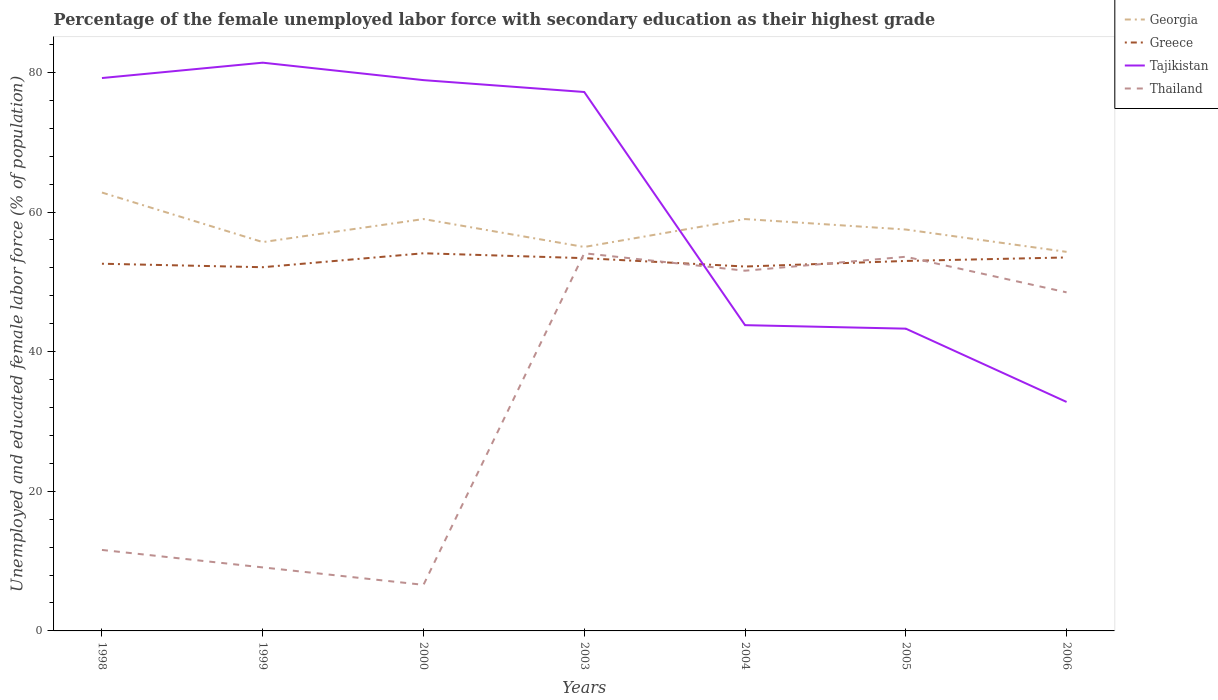Does the line corresponding to Thailand intersect with the line corresponding to Greece?
Offer a terse response. Yes. Is the number of lines equal to the number of legend labels?
Offer a terse response. Yes. Across all years, what is the maximum percentage of the unemployed female labor force with secondary education in Georgia?
Ensure brevity in your answer.  54.3. What is the total percentage of the unemployed female labor force with secondary education in Thailand in the graph?
Offer a terse response. 2.5. What is the difference between the highest and the second highest percentage of the unemployed female labor force with secondary education in Tajikistan?
Make the answer very short. 48.6. Is the percentage of the unemployed female labor force with secondary education in Georgia strictly greater than the percentage of the unemployed female labor force with secondary education in Tajikistan over the years?
Your answer should be compact. No. How many lines are there?
Give a very brief answer. 4. What is the difference between two consecutive major ticks on the Y-axis?
Your answer should be compact. 20. Are the values on the major ticks of Y-axis written in scientific E-notation?
Your response must be concise. No. Does the graph contain any zero values?
Offer a very short reply. No. Where does the legend appear in the graph?
Keep it short and to the point. Top right. How many legend labels are there?
Provide a short and direct response. 4. What is the title of the graph?
Your answer should be compact. Percentage of the female unemployed labor force with secondary education as their highest grade. What is the label or title of the Y-axis?
Keep it short and to the point. Unemployed and educated female labor force (% of population). What is the Unemployed and educated female labor force (% of population) of Georgia in 1998?
Make the answer very short. 62.8. What is the Unemployed and educated female labor force (% of population) in Greece in 1998?
Keep it short and to the point. 52.6. What is the Unemployed and educated female labor force (% of population) in Tajikistan in 1998?
Your answer should be very brief. 79.2. What is the Unemployed and educated female labor force (% of population) in Thailand in 1998?
Your answer should be compact. 11.6. What is the Unemployed and educated female labor force (% of population) in Georgia in 1999?
Keep it short and to the point. 55.7. What is the Unemployed and educated female labor force (% of population) in Greece in 1999?
Offer a terse response. 52.1. What is the Unemployed and educated female labor force (% of population) of Tajikistan in 1999?
Your answer should be very brief. 81.4. What is the Unemployed and educated female labor force (% of population) of Thailand in 1999?
Provide a succinct answer. 9.1. What is the Unemployed and educated female labor force (% of population) of Greece in 2000?
Provide a short and direct response. 54.1. What is the Unemployed and educated female labor force (% of population) of Tajikistan in 2000?
Give a very brief answer. 78.9. What is the Unemployed and educated female labor force (% of population) of Thailand in 2000?
Your response must be concise. 6.6. What is the Unemployed and educated female labor force (% of population) of Greece in 2003?
Offer a terse response. 53.4. What is the Unemployed and educated female labor force (% of population) in Tajikistan in 2003?
Offer a terse response. 77.2. What is the Unemployed and educated female labor force (% of population) of Thailand in 2003?
Your answer should be very brief. 54.1. What is the Unemployed and educated female labor force (% of population) of Greece in 2004?
Your response must be concise. 52.2. What is the Unemployed and educated female labor force (% of population) of Tajikistan in 2004?
Your answer should be very brief. 43.8. What is the Unemployed and educated female labor force (% of population) in Thailand in 2004?
Ensure brevity in your answer.  51.6. What is the Unemployed and educated female labor force (% of population) of Georgia in 2005?
Your response must be concise. 57.5. What is the Unemployed and educated female labor force (% of population) of Tajikistan in 2005?
Offer a very short reply. 43.3. What is the Unemployed and educated female labor force (% of population) in Thailand in 2005?
Keep it short and to the point. 53.6. What is the Unemployed and educated female labor force (% of population) of Georgia in 2006?
Offer a terse response. 54.3. What is the Unemployed and educated female labor force (% of population) of Greece in 2006?
Provide a short and direct response. 53.5. What is the Unemployed and educated female labor force (% of population) in Tajikistan in 2006?
Your answer should be very brief. 32.8. What is the Unemployed and educated female labor force (% of population) of Thailand in 2006?
Provide a succinct answer. 48.5. Across all years, what is the maximum Unemployed and educated female labor force (% of population) in Georgia?
Your response must be concise. 62.8. Across all years, what is the maximum Unemployed and educated female labor force (% of population) of Greece?
Offer a very short reply. 54.1. Across all years, what is the maximum Unemployed and educated female labor force (% of population) in Tajikistan?
Your answer should be very brief. 81.4. Across all years, what is the maximum Unemployed and educated female labor force (% of population) in Thailand?
Your response must be concise. 54.1. Across all years, what is the minimum Unemployed and educated female labor force (% of population) of Georgia?
Your answer should be compact. 54.3. Across all years, what is the minimum Unemployed and educated female labor force (% of population) of Greece?
Give a very brief answer. 52.1. Across all years, what is the minimum Unemployed and educated female labor force (% of population) in Tajikistan?
Your answer should be compact. 32.8. Across all years, what is the minimum Unemployed and educated female labor force (% of population) of Thailand?
Ensure brevity in your answer.  6.6. What is the total Unemployed and educated female labor force (% of population) of Georgia in the graph?
Your answer should be compact. 403.3. What is the total Unemployed and educated female labor force (% of population) of Greece in the graph?
Provide a succinct answer. 370.9. What is the total Unemployed and educated female labor force (% of population) in Tajikistan in the graph?
Offer a very short reply. 436.6. What is the total Unemployed and educated female labor force (% of population) of Thailand in the graph?
Give a very brief answer. 235.1. What is the difference between the Unemployed and educated female labor force (% of population) of Tajikistan in 1998 and that in 1999?
Give a very brief answer. -2.2. What is the difference between the Unemployed and educated female labor force (% of population) of Thailand in 1998 and that in 1999?
Ensure brevity in your answer.  2.5. What is the difference between the Unemployed and educated female labor force (% of population) of Georgia in 1998 and that in 2000?
Your response must be concise. 3.8. What is the difference between the Unemployed and educated female labor force (% of population) in Greece in 1998 and that in 2000?
Your response must be concise. -1.5. What is the difference between the Unemployed and educated female labor force (% of population) of Tajikistan in 1998 and that in 2000?
Your answer should be very brief. 0.3. What is the difference between the Unemployed and educated female labor force (% of population) in Thailand in 1998 and that in 2000?
Offer a very short reply. 5. What is the difference between the Unemployed and educated female labor force (% of population) in Greece in 1998 and that in 2003?
Your response must be concise. -0.8. What is the difference between the Unemployed and educated female labor force (% of population) of Thailand in 1998 and that in 2003?
Your answer should be compact. -42.5. What is the difference between the Unemployed and educated female labor force (% of population) of Tajikistan in 1998 and that in 2004?
Provide a short and direct response. 35.4. What is the difference between the Unemployed and educated female labor force (% of population) of Thailand in 1998 and that in 2004?
Provide a succinct answer. -40. What is the difference between the Unemployed and educated female labor force (% of population) of Georgia in 1998 and that in 2005?
Make the answer very short. 5.3. What is the difference between the Unemployed and educated female labor force (% of population) of Greece in 1998 and that in 2005?
Your answer should be very brief. -0.4. What is the difference between the Unemployed and educated female labor force (% of population) in Tajikistan in 1998 and that in 2005?
Provide a succinct answer. 35.9. What is the difference between the Unemployed and educated female labor force (% of population) in Thailand in 1998 and that in 2005?
Offer a terse response. -42. What is the difference between the Unemployed and educated female labor force (% of population) of Tajikistan in 1998 and that in 2006?
Make the answer very short. 46.4. What is the difference between the Unemployed and educated female labor force (% of population) of Thailand in 1998 and that in 2006?
Make the answer very short. -36.9. What is the difference between the Unemployed and educated female labor force (% of population) of Tajikistan in 1999 and that in 2000?
Ensure brevity in your answer.  2.5. What is the difference between the Unemployed and educated female labor force (% of population) of Thailand in 1999 and that in 2000?
Your answer should be very brief. 2.5. What is the difference between the Unemployed and educated female labor force (% of population) in Greece in 1999 and that in 2003?
Keep it short and to the point. -1.3. What is the difference between the Unemployed and educated female labor force (% of population) of Tajikistan in 1999 and that in 2003?
Your response must be concise. 4.2. What is the difference between the Unemployed and educated female labor force (% of population) in Thailand in 1999 and that in 2003?
Provide a succinct answer. -45. What is the difference between the Unemployed and educated female labor force (% of population) in Georgia in 1999 and that in 2004?
Your answer should be very brief. -3.3. What is the difference between the Unemployed and educated female labor force (% of population) in Tajikistan in 1999 and that in 2004?
Your answer should be compact. 37.6. What is the difference between the Unemployed and educated female labor force (% of population) in Thailand in 1999 and that in 2004?
Offer a very short reply. -42.5. What is the difference between the Unemployed and educated female labor force (% of population) in Georgia in 1999 and that in 2005?
Provide a succinct answer. -1.8. What is the difference between the Unemployed and educated female labor force (% of population) of Greece in 1999 and that in 2005?
Keep it short and to the point. -0.9. What is the difference between the Unemployed and educated female labor force (% of population) of Tajikistan in 1999 and that in 2005?
Offer a terse response. 38.1. What is the difference between the Unemployed and educated female labor force (% of population) of Thailand in 1999 and that in 2005?
Ensure brevity in your answer.  -44.5. What is the difference between the Unemployed and educated female labor force (% of population) in Tajikistan in 1999 and that in 2006?
Provide a succinct answer. 48.6. What is the difference between the Unemployed and educated female labor force (% of population) in Thailand in 1999 and that in 2006?
Keep it short and to the point. -39.4. What is the difference between the Unemployed and educated female labor force (% of population) in Greece in 2000 and that in 2003?
Your answer should be compact. 0.7. What is the difference between the Unemployed and educated female labor force (% of population) of Tajikistan in 2000 and that in 2003?
Ensure brevity in your answer.  1.7. What is the difference between the Unemployed and educated female labor force (% of population) in Thailand in 2000 and that in 2003?
Provide a succinct answer. -47.5. What is the difference between the Unemployed and educated female labor force (% of population) of Georgia in 2000 and that in 2004?
Provide a succinct answer. 0. What is the difference between the Unemployed and educated female labor force (% of population) in Tajikistan in 2000 and that in 2004?
Offer a terse response. 35.1. What is the difference between the Unemployed and educated female labor force (% of population) in Thailand in 2000 and that in 2004?
Keep it short and to the point. -45. What is the difference between the Unemployed and educated female labor force (% of population) in Georgia in 2000 and that in 2005?
Your answer should be compact. 1.5. What is the difference between the Unemployed and educated female labor force (% of population) in Tajikistan in 2000 and that in 2005?
Offer a very short reply. 35.6. What is the difference between the Unemployed and educated female labor force (% of population) of Thailand in 2000 and that in 2005?
Give a very brief answer. -47. What is the difference between the Unemployed and educated female labor force (% of population) of Tajikistan in 2000 and that in 2006?
Provide a succinct answer. 46.1. What is the difference between the Unemployed and educated female labor force (% of population) in Thailand in 2000 and that in 2006?
Give a very brief answer. -41.9. What is the difference between the Unemployed and educated female labor force (% of population) of Tajikistan in 2003 and that in 2004?
Ensure brevity in your answer.  33.4. What is the difference between the Unemployed and educated female labor force (% of population) in Thailand in 2003 and that in 2004?
Your answer should be compact. 2.5. What is the difference between the Unemployed and educated female labor force (% of population) in Tajikistan in 2003 and that in 2005?
Ensure brevity in your answer.  33.9. What is the difference between the Unemployed and educated female labor force (% of population) of Tajikistan in 2003 and that in 2006?
Ensure brevity in your answer.  44.4. What is the difference between the Unemployed and educated female labor force (% of population) in Greece in 2004 and that in 2005?
Make the answer very short. -0.8. What is the difference between the Unemployed and educated female labor force (% of population) in Tajikistan in 2004 and that in 2005?
Ensure brevity in your answer.  0.5. What is the difference between the Unemployed and educated female labor force (% of population) in Georgia in 2004 and that in 2006?
Give a very brief answer. 4.7. What is the difference between the Unemployed and educated female labor force (% of population) of Greece in 2004 and that in 2006?
Your answer should be compact. -1.3. What is the difference between the Unemployed and educated female labor force (% of population) in Thailand in 2004 and that in 2006?
Offer a terse response. 3.1. What is the difference between the Unemployed and educated female labor force (% of population) of Greece in 2005 and that in 2006?
Offer a terse response. -0.5. What is the difference between the Unemployed and educated female labor force (% of population) in Tajikistan in 2005 and that in 2006?
Keep it short and to the point. 10.5. What is the difference between the Unemployed and educated female labor force (% of population) in Thailand in 2005 and that in 2006?
Make the answer very short. 5.1. What is the difference between the Unemployed and educated female labor force (% of population) in Georgia in 1998 and the Unemployed and educated female labor force (% of population) in Tajikistan in 1999?
Give a very brief answer. -18.6. What is the difference between the Unemployed and educated female labor force (% of population) of Georgia in 1998 and the Unemployed and educated female labor force (% of population) of Thailand in 1999?
Ensure brevity in your answer.  53.7. What is the difference between the Unemployed and educated female labor force (% of population) in Greece in 1998 and the Unemployed and educated female labor force (% of population) in Tajikistan in 1999?
Provide a short and direct response. -28.8. What is the difference between the Unemployed and educated female labor force (% of population) of Greece in 1998 and the Unemployed and educated female labor force (% of population) of Thailand in 1999?
Give a very brief answer. 43.5. What is the difference between the Unemployed and educated female labor force (% of population) in Tajikistan in 1998 and the Unemployed and educated female labor force (% of population) in Thailand in 1999?
Make the answer very short. 70.1. What is the difference between the Unemployed and educated female labor force (% of population) of Georgia in 1998 and the Unemployed and educated female labor force (% of population) of Greece in 2000?
Your response must be concise. 8.7. What is the difference between the Unemployed and educated female labor force (% of population) in Georgia in 1998 and the Unemployed and educated female labor force (% of population) in Tajikistan in 2000?
Your answer should be compact. -16.1. What is the difference between the Unemployed and educated female labor force (% of population) in Georgia in 1998 and the Unemployed and educated female labor force (% of population) in Thailand in 2000?
Your answer should be compact. 56.2. What is the difference between the Unemployed and educated female labor force (% of population) of Greece in 1998 and the Unemployed and educated female labor force (% of population) of Tajikistan in 2000?
Your response must be concise. -26.3. What is the difference between the Unemployed and educated female labor force (% of population) of Greece in 1998 and the Unemployed and educated female labor force (% of population) of Thailand in 2000?
Ensure brevity in your answer.  46. What is the difference between the Unemployed and educated female labor force (% of population) of Tajikistan in 1998 and the Unemployed and educated female labor force (% of population) of Thailand in 2000?
Keep it short and to the point. 72.6. What is the difference between the Unemployed and educated female labor force (% of population) in Georgia in 1998 and the Unemployed and educated female labor force (% of population) in Tajikistan in 2003?
Keep it short and to the point. -14.4. What is the difference between the Unemployed and educated female labor force (% of population) in Georgia in 1998 and the Unemployed and educated female labor force (% of population) in Thailand in 2003?
Offer a terse response. 8.7. What is the difference between the Unemployed and educated female labor force (% of population) of Greece in 1998 and the Unemployed and educated female labor force (% of population) of Tajikistan in 2003?
Your answer should be compact. -24.6. What is the difference between the Unemployed and educated female labor force (% of population) of Greece in 1998 and the Unemployed and educated female labor force (% of population) of Thailand in 2003?
Your answer should be compact. -1.5. What is the difference between the Unemployed and educated female labor force (% of population) in Tajikistan in 1998 and the Unemployed and educated female labor force (% of population) in Thailand in 2003?
Make the answer very short. 25.1. What is the difference between the Unemployed and educated female labor force (% of population) in Georgia in 1998 and the Unemployed and educated female labor force (% of population) in Greece in 2004?
Give a very brief answer. 10.6. What is the difference between the Unemployed and educated female labor force (% of population) in Tajikistan in 1998 and the Unemployed and educated female labor force (% of population) in Thailand in 2004?
Your answer should be very brief. 27.6. What is the difference between the Unemployed and educated female labor force (% of population) in Georgia in 1998 and the Unemployed and educated female labor force (% of population) in Greece in 2005?
Make the answer very short. 9.8. What is the difference between the Unemployed and educated female labor force (% of population) in Georgia in 1998 and the Unemployed and educated female labor force (% of population) in Tajikistan in 2005?
Provide a short and direct response. 19.5. What is the difference between the Unemployed and educated female labor force (% of population) in Greece in 1998 and the Unemployed and educated female labor force (% of population) in Tajikistan in 2005?
Provide a short and direct response. 9.3. What is the difference between the Unemployed and educated female labor force (% of population) in Tajikistan in 1998 and the Unemployed and educated female labor force (% of population) in Thailand in 2005?
Give a very brief answer. 25.6. What is the difference between the Unemployed and educated female labor force (% of population) of Georgia in 1998 and the Unemployed and educated female labor force (% of population) of Greece in 2006?
Ensure brevity in your answer.  9.3. What is the difference between the Unemployed and educated female labor force (% of population) in Georgia in 1998 and the Unemployed and educated female labor force (% of population) in Tajikistan in 2006?
Your response must be concise. 30. What is the difference between the Unemployed and educated female labor force (% of population) of Greece in 1998 and the Unemployed and educated female labor force (% of population) of Tajikistan in 2006?
Your response must be concise. 19.8. What is the difference between the Unemployed and educated female labor force (% of population) in Tajikistan in 1998 and the Unemployed and educated female labor force (% of population) in Thailand in 2006?
Offer a very short reply. 30.7. What is the difference between the Unemployed and educated female labor force (% of population) of Georgia in 1999 and the Unemployed and educated female labor force (% of population) of Tajikistan in 2000?
Make the answer very short. -23.2. What is the difference between the Unemployed and educated female labor force (% of population) of Georgia in 1999 and the Unemployed and educated female labor force (% of population) of Thailand in 2000?
Make the answer very short. 49.1. What is the difference between the Unemployed and educated female labor force (% of population) in Greece in 1999 and the Unemployed and educated female labor force (% of population) in Tajikistan in 2000?
Your answer should be compact. -26.8. What is the difference between the Unemployed and educated female labor force (% of population) of Greece in 1999 and the Unemployed and educated female labor force (% of population) of Thailand in 2000?
Ensure brevity in your answer.  45.5. What is the difference between the Unemployed and educated female labor force (% of population) of Tajikistan in 1999 and the Unemployed and educated female labor force (% of population) of Thailand in 2000?
Make the answer very short. 74.8. What is the difference between the Unemployed and educated female labor force (% of population) in Georgia in 1999 and the Unemployed and educated female labor force (% of population) in Greece in 2003?
Your answer should be very brief. 2.3. What is the difference between the Unemployed and educated female labor force (% of population) of Georgia in 1999 and the Unemployed and educated female labor force (% of population) of Tajikistan in 2003?
Keep it short and to the point. -21.5. What is the difference between the Unemployed and educated female labor force (% of population) in Georgia in 1999 and the Unemployed and educated female labor force (% of population) in Thailand in 2003?
Give a very brief answer. 1.6. What is the difference between the Unemployed and educated female labor force (% of population) of Greece in 1999 and the Unemployed and educated female labor force (% of population) of Tajikistan in 2003?
Your answer should be compact. -25.1. What is the difference between the Unemployed and educated female labor force (% of population) of Tajikistan in 1999 and the Unemployed and educated female labor force (% of population) of Thailand in 2003?
Ensure brevity in your answer.  27.3. What is the difference between the Unemployed and educated female labor force (% of population) of Georgia in 1999 and the Unemployed and educated female labor force (% of population) of Thailand in 2004?
Offer a terse response. 4.1. What is the difference between the Unemployed and educated female labor force (% of population) in Greece in 1999 and the Unemployed and educated female labor force (% of population) in Thailand in 2004?
Your answer should be compact. 0.5. What is the difference between the Unemployed and educated female labor force (% of population) of Tajikistan in 1999 and the Unemployed and educated female labor force (% of population) of Thailand in 2004?
Make the answer very short. 29.8. What is the difference between the Unemployed and educated female labor force (% of population) in Georgia in 1999 and the Unemployed and educated female labor force (% of population) in Tajikistan in 2005?
Provide a short and direct response. 12.4. What is the difference between the Unemployed and educated female labor force (% of population) in Tajikistan in 1999 and the Unemployed and educated female labor force (% of population) in Thailand in 2005?
Make the answer very short. 27.8. What is the difference between the Unemployed and educated female labor force (% of population) of Georgia in 1999 and the Unemployed and educated female labor force (% of population) of Tajikistan in 2006?
Offer a terse response. 22.9. What is the difference between the Unemployed and educated female labor force (% of population) of Greece in 1999 and the Unemployed and educated female labor force (% of population) of Tajikistan in 2006?
Provide a short and direct response. 19.3. What is the difference between the Unemployed and educated female labor force (% of population) in Greece in 1999 and the Unemployed and educated female labor force (% of population) in Thailand in 2006?
Provide a short and direct response. 3.6. What is the difference between the Unemployed and educated female labor force (% of population) of Tajikistan in 1999 and the Unemployed and educated female labor force (% of population) of Thailand in 2006?
Your answer should be very brief. 32.9. What is the difference between the Unemployed and educated female labor force (% of population) of Georgia in 2000 and the Unemployed and educated female labor force (% of population) of Tajikistan in 2003?
Offer a terse response. -18.2. What is the difference between the Unemployed and educated female labor force (% of population) of Greece in 2000 and the Unemployed and educated female labor force (% of population) of Tajikistan in 2003?
Provide a succinct answer. -23.1. What is the difference between the Unemployed and educated female labor force (% of population) in Greece in 2000 and the Unemployed and educated female labor force (% of population) in Thailand in 2003?
Provide a short and direct response. 0. What is the difference between the Unemployed and educated female labor force (% of population) in Tajikistan in 2000 and the Unemployed and educated female labor force (% of population) in Thailand in 2003?
Your response must be concise. 24.8. What is the difference between the Unemployed and educated female labor force (% of population) of Georgia in 2000 and the Unemployed and educated female labor force (% of population) of Tajikistan in 2004?
Offer a very short reply. 15.2. What is the difference between the Unemployed and educated female labor force (% of population) in Georgia in 2000 and the Unemployed and educated female labor force (% of population) in Thailand in 2004?
Your answer should be compact. 7.4. What is the difference between the Unemployed and educated female labor force (% of population) of Tajikistan in 2000 and the Unemployed and educated female labor force (% of population) of Thailand in 2004?
Your answer should be very brief. 27.3. What is the difference between the Unemployed and educated female labor force (% of population) of Georgia in 2000 and the Unemployed and educated female labor force (% of population) of Greece in 2005?
Give a very brief answer. 6. What is the difference between the Unemployed and educated female labor force (% of population) of Georgia in 2000 and the Unemployed and educated female labor force (% of population) of Tajikistan in 2005?
Give a very brief answer. 15.7. What is the difference between the Unemployed and educated female labor force (% of population) of Georgia in 2000 and the Unemployed and educated female labor force (% of population) of Thailand in 2005?
Make the answer very short. 5.4. What is the difference between the Unemployed and educated female labor force (% of population) in Tajikistan in 2000 and the Unemployed and educated female labor force (% of population) in Thailand in 2005?
Your response must be concise. 25.3. What is the difference between the Unemployed and educated female labor force (% of population) of Georgia in 2000 and the Unemployed and educated female labor force (% of population) of Greece in 2006?
Offer a terse response. 5.5. What is the difference between the Unemployed and educated female labor force (% of population) of Georgia in 2000 and the Unemployed and educated female labor force (% of population) of Tajikistan in 2006?
Keep it short and to the point. 26.2. What is the difference between the Unemployed and educated female labor force (% of population) of Georgia in 2000 and the Unemployed and educated female labor force (% of population) of Thailand in 2006?
Your answer should be compact. 10.5. What is the difference between the Unemployed and educated female labor force (% of population) in Greece in 2000 and the Unemployed and educated female labor force (% of population) in Tajikistan in 2006?
Your answer should be compact. 21.3. What is the difference between the Unemployed and educated female labor force (% of population) in Greece in 2000 and the Unemployed and educated female labor force (% of population) in Thailand in 2006?
Provide a short and direct response. 5.6. What is the difference between the Unemployed and educated female labor force (% of population) in Tajikistan in 2000 and the Unemployed and educated female labor force (% of population) in Thailand in 2006?
Make the answer very short. 30.4. What is the difference between the Unemployed and educated female labor force (% of population) of Georgia in 2003 and the Unemployed and educated female labor force (% of population) of Greece in 2004?
Your answer should be compact. 2.8. What is the difference between the Unemployed and educated female labor force (% of population) in Georgia in 2003 and the Unemployed and educated female labor force (% of population) in Tajikistan in 2004?
Offer a terse response. 11.2. What is the difference between the Unemployed and educated female labor force (% of population) in Greece in 2003 and the Unemployed and educated female labor force (% of population) in Tajikistan in 2004?
Ensure brevity in your answer.  9.6. What is the difference between the Unemployed and educated female labor force (% of population) of Tajikistan in 2003 and the Unemployed and educated female labor force (% of population) of Thailand in 2004?
Provide a short and direct response. 25.6. What is the difference between the Unemployed and educated female labor force (% of population) of Georgia in 2003 and the Unemployed and educated female labor force (% of population) of Greece in 2005?
Offer a terse response. 2. What is the difference between the Unemployed and educated female labor force (% of population) in Tajikistan in 2003 and the Unemployed and educated female labor force (% of population) in Thailand in 2005?
Provide a short and direct response. 23.6. What is the difference between the Unemployed and educated female labor force (% of population) in Georgia in 2003 and the Unemployed and educated female labor force (% of population) in Tajikistan in 2006?
Make the answer very short. 22.2. What is the difference between the Unemployed and educated female labor force (% of population) of Georgia in 2003 and the Unemployed and educated female labor force (% of population) of Thailand in 2006?
Your answer should be very brief. 6.5. What is the difference between the Unemployed and educated female labor force (% of population) in Greece in 2003 and the Unemployed and educated female labor force (% of population) in Tajikistan in 2006?
Your response must be concise. 20.6. What is the difference between the Unemployed and educated female labor force (% of population) in Greece in 2003 and the Unemployed and educated female labor force (% of population) in Thailand in 2006?
Offer a very short reply. 4.9. What is the difference between the Unemployed and educated female labor force (% of population) of Tajikistan in 2003 and the Unemployed and educated female labor force (% of population) of Thailand in 2006?
Your response must be concise. 28.7. What is the difference between the Unemployed and educated female labor force (% of population) of Georgia in 2004 and the Unemployed and educated female labor force (% of population) of Thailand in 2005?
Provide a succinct answer. 5.4. What is the difference between the Unemployed and educated female labor force (% of population) in Greece in 2004 and the Unemployed and educated female labor force (% of population) in Tajikistan in 2005?
Offer a very short reply. 8.9. What is the difference between the Unemployed and educated female labor force (% of population) of Greece in 2004 and the Unemployed and educated female labor force (% of population) of Thailand in 2005?
Offer a very short reply. -1.4. What is the difference between the Unemployed and educated female labor force (% of population) of Georgia in 2004 and the Unemployed and educated female labor force (% of population) of Tajikistan in 2006?
Ensure brevity in your answer.  26.2. What is the difference between the Unemployed and educated female labor force (% of population) of Georgia in 2004 and the Unemployed and educated female labor force (% of population) of Thailand in 2006?
Keep it short and to the point. 10.5. What is the difference between the Unemployed and educated female labor force (% of population) of Greece in 2004 and the Unemployed and educated female labor force (% of population) of Tajikistan in 2006?
Offer a terse response. 19.4. What is the difference between the Unemployed and educated female labor force (% of population) of Greece in 2004 and the Unemployed and educated female labor force (% of population) of Thailand in 2006?
Your answer should be compact. 3.7. What is the difference between the Unemployed and educated female labor force (% of population) of Georgia in 2005 and the Unemployed and educated female labor force (% of population) of Tajikistan in 2006?
Provide a succinct answer. 24.7. What is the difference between the Unemployed and educated female labor force (% of population) in Greece in 2005 and the Unemployed and educated female labor force (% of population) in Tajikistan in 2006?
Make the answer very short. 20.2. What is the difference between the Unemployed and educated female labor force (% of population) of Greece in 2005 and the Unemployed and educated female labor force (% of population) of Thailand in 2006?
Ensure brevity in your answer.  4.5. What is the difference between the Unemployed and educated female labor force (% of population) of Tajikistan in 2005 and the Unemployed and educated female labor force (% of population) of Thailand in 2006?
Give a very brief answer. -5.2. What is the average Unemployed and educated female labor force (% of population) of Georgia per year?
Make the answer very short. 57.61. What is the average Unemployed and educated female labor force (% of population) in Greece per year?
Your answer should be very brief. 52.99. What is the average Unemployed and educated female labor force (% of population) in Tajikistan per year?
Make the answer very short. 62.37. What is the average Unemployed and educated female labor force (% of population) of Thailand per year?
Make the answer very short. 33.59. In the year 1998, what is the difference between the Unemployed and educated female labor force (% of population) in Georgia and Unemployed and educated female labor force (% of population) in Greece?
Provide a succinct answer. 10.2. In the year 1998, what is the difference between the Unemployed and educated female labor force (% of population) of Georgia and Unemployed and educated female labor force (% of population) of Tajikistan?
Provide a short and direct response. -16.4. In the year 1998, what is the difference between the Unemployed and educated female labor force (% of population) in Georgia and Unemployed and educated female labor force (% of population) in Thailand?
Your answer should be very brief. 51.2. In the year 1998, what is the difference between the Unemployed and educated female labor force (% of population) in Greece and Unemployed and educated female labor force (% of population) in Tajikistan?
Your answer should be compact. -26.6. In the year 1998, what is the difference between the Unemployed and educated female labor force (% of population) of Greece and Unemployed and educated female labor force (% of population) of Thailand?
Make the answer very short. 41. In the year 1998, what is the difference between the Unemployed and educated female labor force (% of population) of Tajikistan and Unemployed and educated female labor force (% of population) of Thailand?
Keep it short and to the point. 67.6. In the year 1999, what is the difference between the Unemployed and educated female labor force (% of population) in Georgia and Unemployed and educated female labor force (% of population) in Tajikistan?
Provide a short and direct response. -25.7. In the year 1999, what is the difference between the Unemployed and educated female labor force (% of population) in Georgia and Unemployed and educated female labor force (% of population) in Thailand?
Provide a succinct answer. 46.6. In the year 1999, what is the difference between the Unemployed and educated female labor force (% of population) in Greece and Unemployed and educated female labor force (% of population) in Tajikistan?
Make the answer very short. -29.3. In the year 1999, what is the difference between the Unemployed and educated female labor force (% of population) of Greece and Unemployed and educated female labor force (% of population) of Thailand?
Your response must be concise. 43. In the year 1999, what is the difference between the Unemployed and educated female labor force (% of population) of Tajikistan and Unemployed and educated female labor force (% of population) of Thailand?
Ensure brevity in your answer.  72.3. In the year 2000, what is the difference between the Unemployed and educated female labor force (% of population) of Georgia and Unemployed and educated female labor force (% of population) of Greece?
Make the answer very short. 4.9. In the year 2000, what is the difference between the Unemployed and educated female labor force (% of population) in Georgia and Unemployed and educated female labor force (% of population) in Tajikistan?
Your answer should be very brief. -19.9. In the year 2000, what is the difference between the Unemployed and educated female labor force (% of population) in Georgia and Unemployed and educated female labor force (% of population) in Thailand?
Your answer should be compact. 52.4. In the year 2000, what is the difference between the Unemployed and educated female labor force (% of population) in Greece and Unemployed and educated female labor force (% of population) in Tajikistan?
Provide a succinct answer. -24.8. In the year 2000, what is the difference between the Unemployed and educated female labor force (% of population) in Greece and Unemployed and educated female labor force (% of population) in Thailand?
Ensure brevity in your answer.  47.5. In the year 2000, what is the difference between the Unemployed and educated female labor force (% of population) of Tajikistan and Unemployed and educated female labor force (% of population) of Thailand?
Offer a very short reply. 72.3. In the year 2003, what is the difference between the Unemployed and educated female labor force (% of population) in Georgia and Unemployed and educated female labor force (% of population) in Greece?
Provide a succinct answer. 1.6. In the year 2003, what is the difference between the Unemployed and educated female labor force (% of population) in Georgia and Unemployed and educated female labor force (% of population) in Tajikistan?
Offer a terse response. -22.2. In the year 2003, what is the difference between the Unemployed and educated female labor force (% of population) of Georgia and Unemployed and educated female labor force (% of population) of Thailand?
Your answer should be very brief. 0.9. In the year 2003, what is the difference between the Unemployed and educated female labor force (% of population) in Greece and Unemployed and educated female labor force (% of population) in Tajikistan?
Make the answer very short. -23.8. In the year 2003, what is the difference between the Unemployed and educated female labor force (% of population) of Tajikistan and Unemployed and educated female labor force (% of population) of Thailand?
Make the answer very short. 23.1. In the year 2004, what is the difference between the Unemployed and educated female labor force (% of population) in Greece and Unemployed and educated female labor force (% of population) in Tajikistan?
Provide a short and direct response. 8.4. In the year 2005, what is the difference between the Unemployed and educated female labor force (% of population) in Greece and Unemployed and educated female labor force (% of population) in Tajikistan?
Offer a terse response. 9.7. In the year 2006, what is the difference between the Unemployed and educated female labor force (% of population) of Greece and Unemployed and educated female labor force (% of population) of Tajikistan?
Your response must be concise. 20.7. In the year 2006, what is the difference between the Unemployed and educated female labor force (% of population) in Tajikistan and Unemployed and educated female labor force (% of population) in Thailand?
Make the answer very short. -15.7. What is the ratio of the Unemployed and educated female labor force (% of population) in Georgia in 1998 to that in 1999?
Offer a terse response. 1.13. What is the ratio of the Unemployed and educated female labor force (% of population) in Greece in 1998 to that in 1999?
Your response must be concise. 1.01. What is the ratio of the Unemployed and educated female labor force (% of population) in Tajikistan in 1998 to that in 1999?
Make the answer very short. 0.97. What is the ratio of the Unemployed and educated female labor force (% of population) of Thailand in 1998 to that in 1999?
Provide a succinct answer. 1.27. What is the ratio of the Unemployed and educated female labor force (% of population) in Georgia in 1998 to that in 2000?
Give a very brief answer. 1.06. What is the ratio of the Unemployed and educated female labor force (% of population) of Greece in 1998 to that in 2000?
Your answer should be compact. 0.97. What is the ratio of the Unemployed and educated female labor force (% of population) of Thailand in 1998 to that in 2000?
Your response must be concise. 1.76. What is the ratio of the Unemployed and educated female labor force (% of population) of Georgia in 1998 to that in 2003?
Your answer should be compact. 1.14. What is the ratio of the Unemployed and educated female labor force (% of population) in Greece in 1998 to that in 2003?
Offer a very short reply. 0.98. What is the ratio of the Unemployed and educated female labor force (% of population) of Tajikistan in 1998 to that in 2003?
Keep it short and to the point. 1.03. What is the ratio of the Unemployed and educated female labor force (% of population) of Thailand in 1998 to that in 2003?
Your answer should be compact. 0.21. What is the ratio of the Unemployed and educated female labor force (% of population) in Georgia in 1998 to that in 2004?
Provide a short and direct response. 1.06. What is the ratio of the Unemployed and educated female labor force (% of population) of Greece in 1998 to that in 2004?
Keep it short and to the point. 1.01. What is the ratio of the Unemployed and educated female labor force (% of population) of Tajikistan in 1998 to that in 2004?
Your response must be concise. 1.81. What is the ratio of the Unemployed and educated female labor force (% of population) in Thailand in 1998 to that in 2004?
Provide a short and direct response. 0.22. What is the ratio of the Unemployed and educated female labor force (% of population) in Georgia in 1998 to that in 2005?
Keep it short and to the point. 1.09. What is the ratio of the Unemployed and educated female labor force (% of population) in Greece in 1998 to that in 2005?
Offer a very short reply. 0.99. What is the ratio of the Unemployed and educated female labor force (% of population) of Tajikistan in 1998 to that in 2005?
Your answer should be compact. 1.83. What is the ratio of the Unemployed and educated female labor force (% of population) of Thailand in 1998 to that in 2005?
Offer a terse response. 0.22. What is the ratio of the Unemployed and educated female labor force (% of population) in Georgia in 1998 to that in 2006?
Provide a short and direct response. 1.16. What is the ratio of the Unemployed and educated female labor force (% of population) of Greece in 1998 to that in 2006?
Provide a succinct answer. 0.98. What is the ratio of the Unemployed and educated female labor force (% of population) of Tajikistan in 1998 to that in 2006?
Offer a very short reply. 2.41. What is the ratio of the Unemployed and educated female labor force (% of population) in Thailand in 1998 to that in 2006?
Your answer should be compact. 0.24. What is the ratio of the Unemployed and educated female labor force (% of population) in Georgia in 1999 to that in 2000?
Your answer should be very brief. 0.94. What is the ratio of the Unemployed and educated female labor force (% of population) in Greece in 1999 to that in 2000?
Provide a succinct answer. 0.96. What is the ratio of the Unemployed and educated female labor force (% of population) of Tajikistan in 1999 to that in 2000?
Your answer should be very brief. 1.03. What is the ratio of the Unemployed and educated female labor force (% of population) in Thailand in 1999 to that in 2000?
Keep it short and to the point. 1.38. What is the ratio of the Unemployed and educated female labor force (% of population) in Georgia in 1999 to that in 2003?
Provide a short and direct response. 1.01. What is the ratio of the Unemployed and educated female labor force (% of population) in Greece in 1999 to that in 2003?
Ensure brevity in your answer.  0.98. What is the ratio of the Unemployed and educated female labor force (% of population) in Tajikistan in 1999 to that in 2003?
Provide a short and direct response. 1.05. What is the ratio of the Unemployed and educated female labor force (% of population) of Thailand in 1999 to that in 2003?
Your response must be concise. 0.17. What is the ratio of the Unemployed and educated female labor force (% of population) of Georgia in 1999 to that in 2004?
Make the answer very short. 0.94. What is the ratio of the Unemployed and educated female labor force (% of population) in Tajikistan in 1999 to that in 2004?
Give a very brief answer. 1.86. What is the ratio of the Unemployed and educated female labor force (% of population) in Thailand in 1999 to that in 2004?
Make the answer very short. 0.18. What is the ratio of the Unemployed and educated female labor force (% of population) of Georgia in 1999 to that in 2005?
Keep it short and to the point. 0.97. What is the ratio of the Unemployed and educated female labor force (% of population) of Greece in 1999 to that in 2005?
Ensure brevity in your answer.  0.98. What is the ratio of the Unemployed and educated female labor force (% of population) of Tajikistan in 1999 to that in 2005?
Provide a succinct answer. 1.88. What is the ratio of the Unemployed and educated female labor force (% of population) in Thailand in 1999 to that in 2005?
Offer a very short reply. 0.17. What is the ratio of the Unemployed and educated female labor force (% of population) of Georgia in 1999 to that in 2006?
Keep it short and to the point. 1.03. What is the ratio of the Unemployed and educated female labor force (% of population) in Greece in 1999 to that in 2006?
Make the answer very short. 0.97. What is the ratio of the Unemployed and educated female labor force (% of population) in Tajikistan in 1999 to that in 2006?
Your answer should be compact. 2.48. What is the ratio of the Unemployed and educated female labor force (% of population) of Thailand in 1999 to that in 2006?
Ensure brevity in your answer.  0.19. What is the ratio of the Unemployed and educated female labor force (% of population) of Georgia in 2000 to that in 2003?
Your response must be concise. 1.07. What is the ratio of the Unemployed and educated female labor force (% of population) in Greece in 2000 to that in 2003?
Offer a very short reply. 1.01. What is the ratio of the Unemployed and educated female labor force (% of population) in Tajikistan in 2000 to that in 2003?
Offer a terse response. 1.02. What is the ratio of the Unemployed and educated female labor force (% of population) in Thailand in 2000 to that in 2003?
Your response must be concise. 0.12. What is the ratio of the Unemployed and educated female labor force (% of population) of Greece in 2000 to that in 2004?
Keep it short and to the point. 1.04. What is the ratio of the Unemployed and educated female labor force (% of population) in Tajikistan in 2000 to that in 2004?
Keep it short and to the point. 1.8. What is the ratio of the Unemployed and educated female labor force (% of population) in Thailand in 2000 to that in 2004?
Make the answer very short. 0.13. What is the ratio of the Unemployed and educated female labor force (% of population) of Georgia in 2000 to that in 2005?
Make the answer very short. 1.03. What is the ratio of the Unemployed and educated female labor force (% of population) in Greece in 2000 to that in 2005?
Offer a very short reply. 1.02. What is the ratio of the Unemployed and educated female labor force (% of population) of Tajikistan in 2000 to that in 2005?
Provide a short and direct response. 1.82. What is the ratio of the Unemployed and educated female labor force (% of population) of Thailand in 2000 to that in 2005?
Keep it short and to the point. 0.12. What is the ratio of the Unemployed and educated female labor force (% of population) in Georgia in 2000 to that in 2006?
Your answer should be very brief. 1.09. What is the ratio of the Unemployed and educated female labor force (% of population) in Greece in 2000 to that in 2006?
Provide a short and direct response. 1.01. What is the ratio of the Unemployed and educated female labor force (% of population) in Tajikistan in 2000 to that in 2006?
Offer a terse response. 2.41. What is the ratio of the Unemployed and educated female labor force (% of population) of Thailand in 2000 to that in 2006?
Offer a very short reply. 0.14. What is the ratio of the Unemployed and educated female labor force (% of population) in Georgia in 2003 to that in 2004?
Provide a short and direct response. 0.93. What is the ratio of the Unemployed and educated female labor force (% of population) in Greece in 2003 to that in 2004?
Give a very brief answer. 1.02. What is the ratio of the Unemployed and educated female labor force (% of population) of Tajikistan in 2003 to that in 2004?
Your answer should be very brief. 1.76. What is the ratio of the Unemployed and educated female labor force (% of population) of Thailand in 2003 to that in 2004?
Provide a short and direct response. 1.05. What is the ratio of the Unemployed and educated female labor force (% of population) of Georgia in 2003 to that in 2005?
Your answer should be very brief. 0.96. What is the ratio of the Unemployed and educated female labor force (% of population) in Greece in 2003 to that in 2005?
Offer a very short reply. 1.01. What is the ratio of the Unemployed and educated female labor force (% of population) of Tajikistan in 2003 to that in 2005?
Offer a very short reply. 1.78. What is the ratio of the Unemployed and educated female labor force (% of population) in Thailand in 2003 to that in 2005?
Ensure brevity in your answer.  1.01. What is the ratio of the Unemployed and educated female labor force (% of population) of Georgia in 2003 to that in 2006?
Your response must be concise. 1.01. What is the ratio of the Unemployed and educated female labor force (% of population) in Tajikistan in 2003 to that in 2006?
Offer a terse response. 2.35. What is the ratio of the Unemployed and educated female labor force (% of population) of Thailand in 2003 to that in 2006?
Provide a succinct answer. 1.12. What is the ratio of the Unemployed and educated female labor force (% of population) of Georgia in 2004 to that in 2005?
Make the answer very short. 1.03. What is the ratio of the Unemployed and educated female labor force (% of population) of Greece in 2004 to that in 2005?
Your answer should be compact. 0.98. What is the ratio of the Unemployed and educated female labor force (% of population) of Tajikistan in 2004 to that in 2005?
Give a very brief answer. 1.01. What is the ratio of the Unemployed and educated female labor force (% of population) in Thailand in 2004 to that in 2005?
Your answer should be very brief. 0.96. What is the ratio of the Unemployed and educated female labor force (% of population) in Georgia in 2004 to that in 2006?
Offer a terse response. 1.09. What is the ratio of the Unemployed and educated female labor force (% of population) of Greece in 2004 to that in 2006?
Your answer should be very brief. 0.98. What is the ratio of the Unemployed and educated female labor force (% of population) of Tajikistan in 2004 to that in 2006?
Your answer should be very brief. 1.34. What is the ratio of the Unemployed and educated female labor force (% of population) of Thailand in 2004 to that in 2006?
Your answer should be very brief. 1.06. What is the ratio of the Unemployed and educated female labor force (% of population) of Georgia in 2005 to that in 2006?
Ensure brevity in your answer.  1.06. What is the ratio of the Unemployed and educated female labor force (% of population) in Tajikistan in 2005 to that in 2006?
Make the answer very short. 1.32. What is the ratio of the Unemployed and educated female labor force (% of population) in Thailand in 2005 to that in 2006?
Your answer should be very brief. 1.11. What is the difference between the highest and the second highest Unemployed and educated female labor force (% of population) in Thailand?
Offer a terse response. 0.5. What is the difference between the highest and the lowest Unemployed and educated female labor force (% of population) of Georgia?
Offer a very short reply. 8.5. What is the difference between the highest and the lowest Unemployed and educated female labor force (% of population) of Tajikistan?
Provide a short and direct response. 48.6. What is the difference between the highest and the lowest Unemployed and educated female labor force (% of population) of Thailand?
Provide a short and direct response. 47.5. 